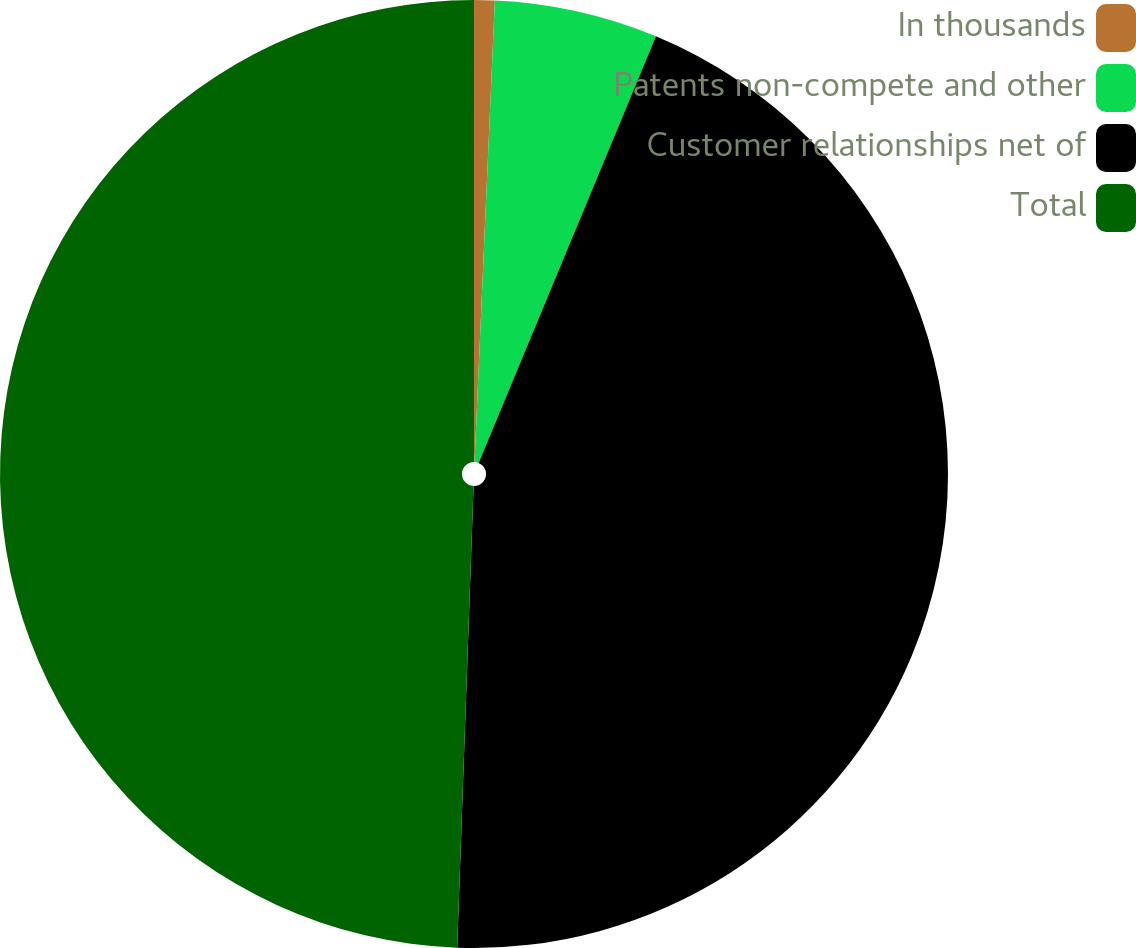<chart> <loc_0><loc_0><loc_500><loc_500><pie_chart><fcel>In thousands<fcel>Patents non-compete and other<fcel>Customer relationships net of<fcel>Total<nl><fcel>0.7%<fcel>5.57%<fcel>44.3%<fcel>49.44%<nl></chart> 